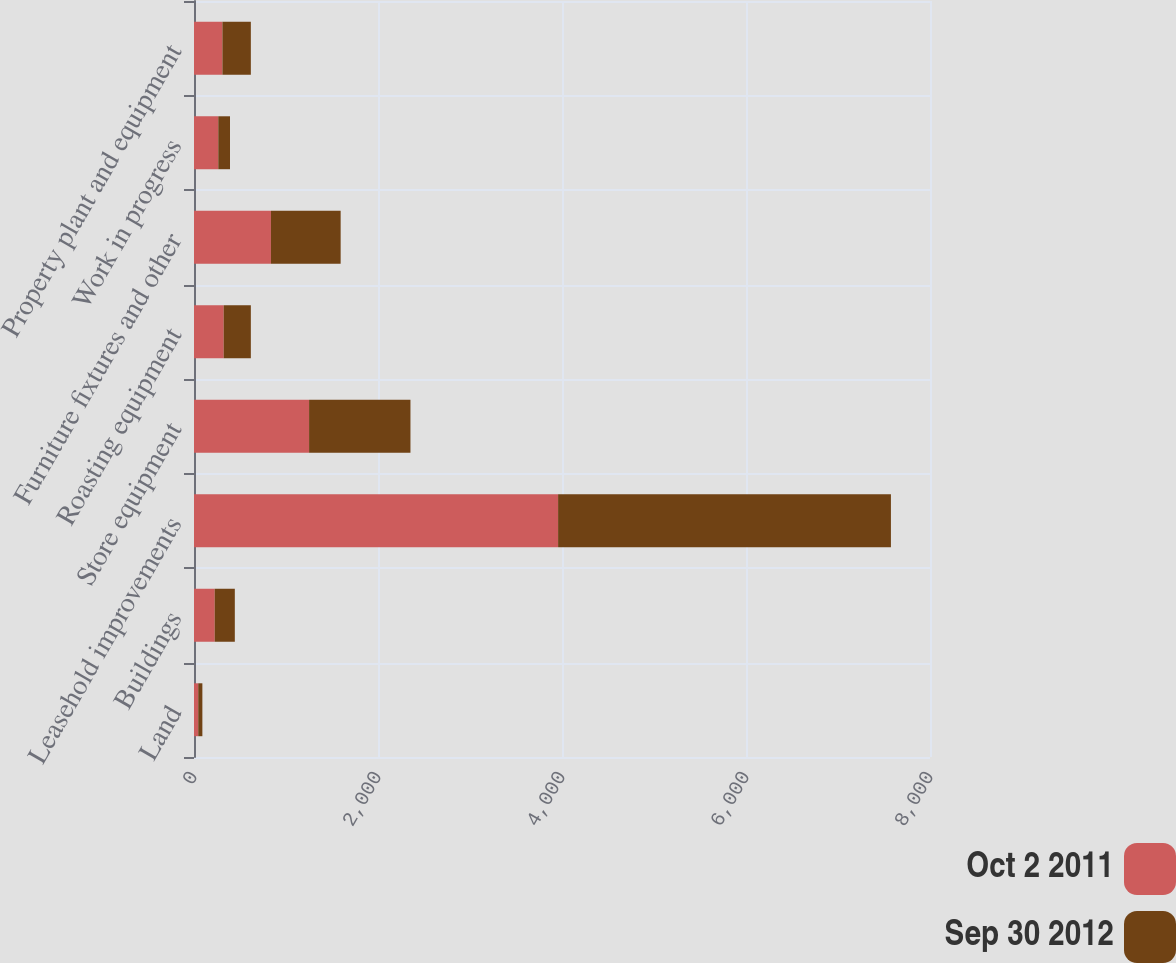Convert chart to OTSL. <chart><loc_0><loc_0><loc_500><loc_500><stacked_bar_chart><ecel><fcel>Land<fcel>Buildings<fcel>Leasehold improvements<fcel>Store equipment<fcel>Roasting equipment<fcel>Furniture fixtures and other<fcel>Work in progress<fcel>Property plant and equipment<nl><fcel>Oct 2 2011<fcel>46.2<fcel>225.2<fcel>3957.6<fcel>1251<fcel>322.8<fcel>836.2<fcel>264.1<fcel>308.95<nl><fcel>Sep 30 2012<fcel>44.8<fcel>218.5<fcel>3617.7<fcel>1101.8<fcel>295.1<fcel>757.8<fcel>127.4<fcel>308.95<nl></chart> 